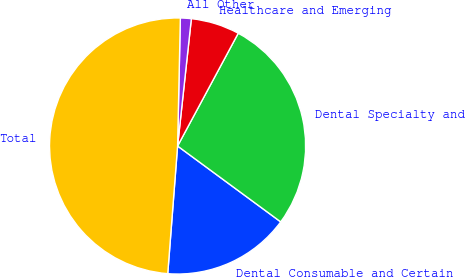Convert chart. <chart><loc_0><loc_0><loc_500><loc_500><pie_chart><fcel>Dental Consumable and Certain<fcel>Dental Specialty and<fcel>Healthcare and Emerging<fcel>All Other<fcel>Total<nl><fcel>16.13%<fcel>27.24%<fcel>6.14%<fcel>1.37%<fcel>49.12%<nl></chart> 